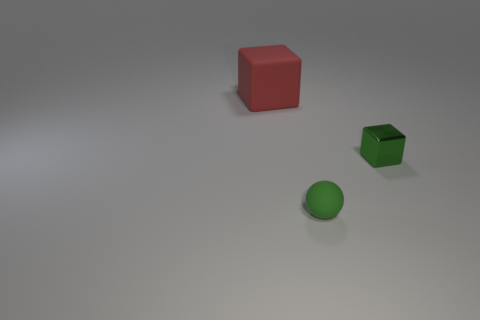There is a rubber thing that is right of the cube on the left side of the green metal cube; what shape is it? sphere 